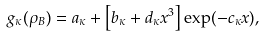<formula> <loc_0><loc_0><loc_500><loc_500>g _ { \kappa } ( \rho _ { B } ) = a _ { \kappa } + \left [ b _ { \kappa } + d _ { \kappa } x ^ { 3 } \right ] \exp ( - c _ { \kappa } x ) ,</formula> 